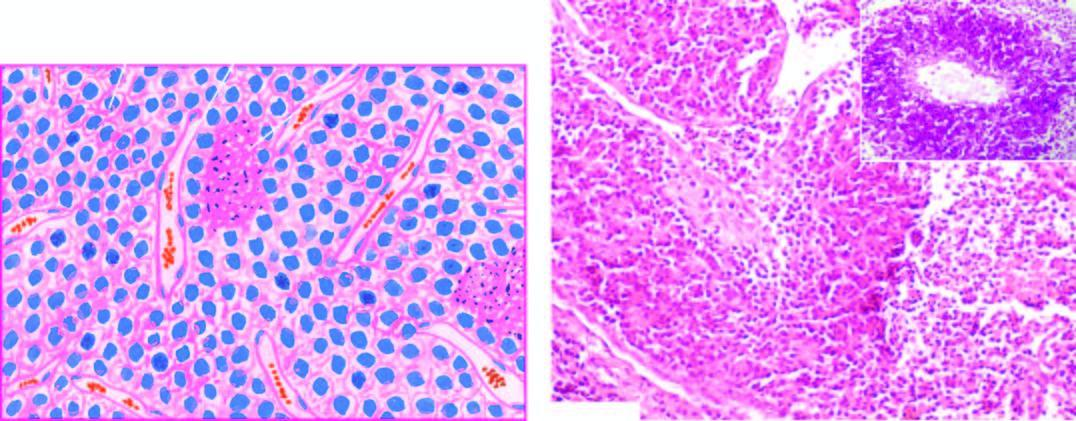re characteristic microscopic features irregular lobules of uniform small tumour cells with indistinct cytoplasmic outlines which are separated by fibrous tissue septa having rich vascularity?
Answer the question using a single word or phrase. Yes 